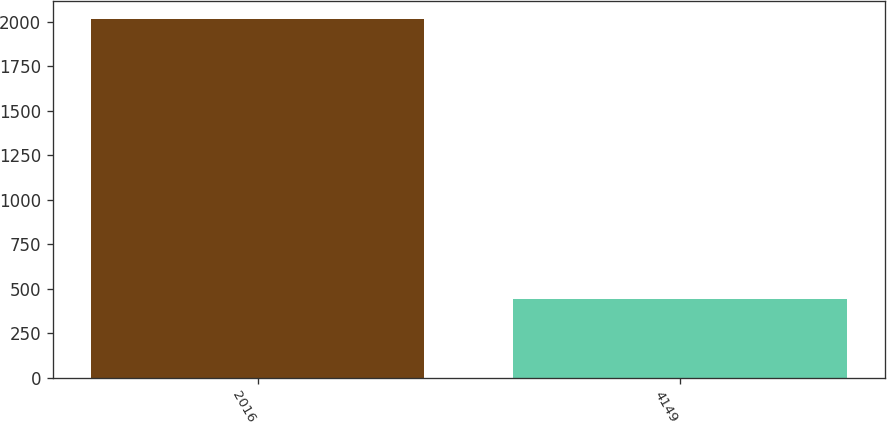<chart> <loc_0><loc_0><loc_500><loc_500><bar_chart><fcel>2016<fcel>4149<nl><fcel>2015<fcel>442<nl></chart> 